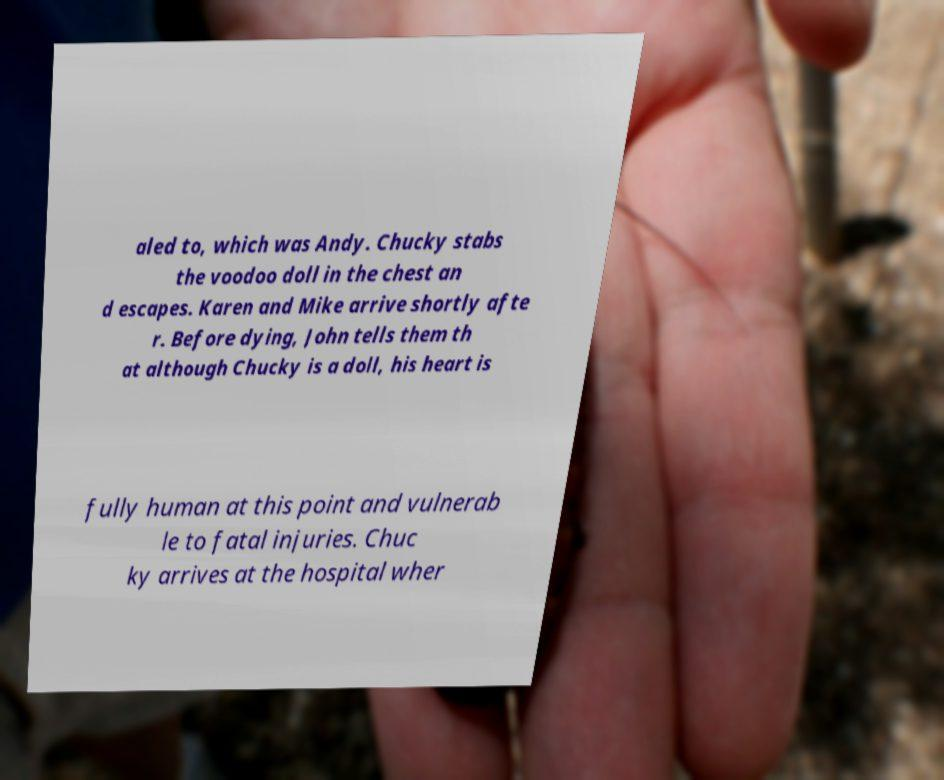Could you assist in decoding the text presented in this image and type it out clearly? aled to, which was Andy. Chucky stabs the voodoo doll in the chest an d escapes. Karen and Mike arrive shortly afte r. Before dying, John tells them th at although Chucky is a doll, his heart is fully human at this point and vulnerab le to fatal injuries. Chuc ky arrives at the hospital wher 